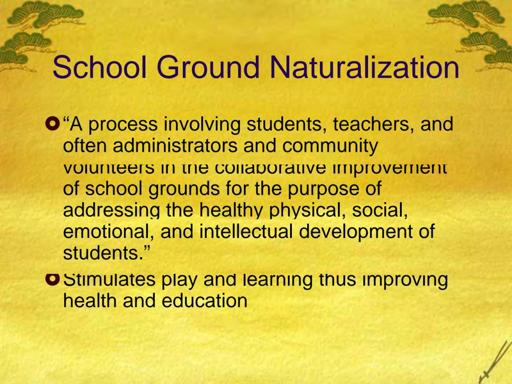What is school ground naturalization? School ground naturalization is a collaborative and transformative initiative that involves students, teachers, administrators, and community members. The process enhances school grounds to promote the holistic development of students, integrating natural features like trees, green spaces, and gardens. This not only enriches the physical environment but also supports students’ physical, social, emotional, and intellectual growth. Engaging in naturalization projects can lead to increased environmental awareness among students and create inviting outdoor learning environments that stimulate creative play and educational opportunities. 